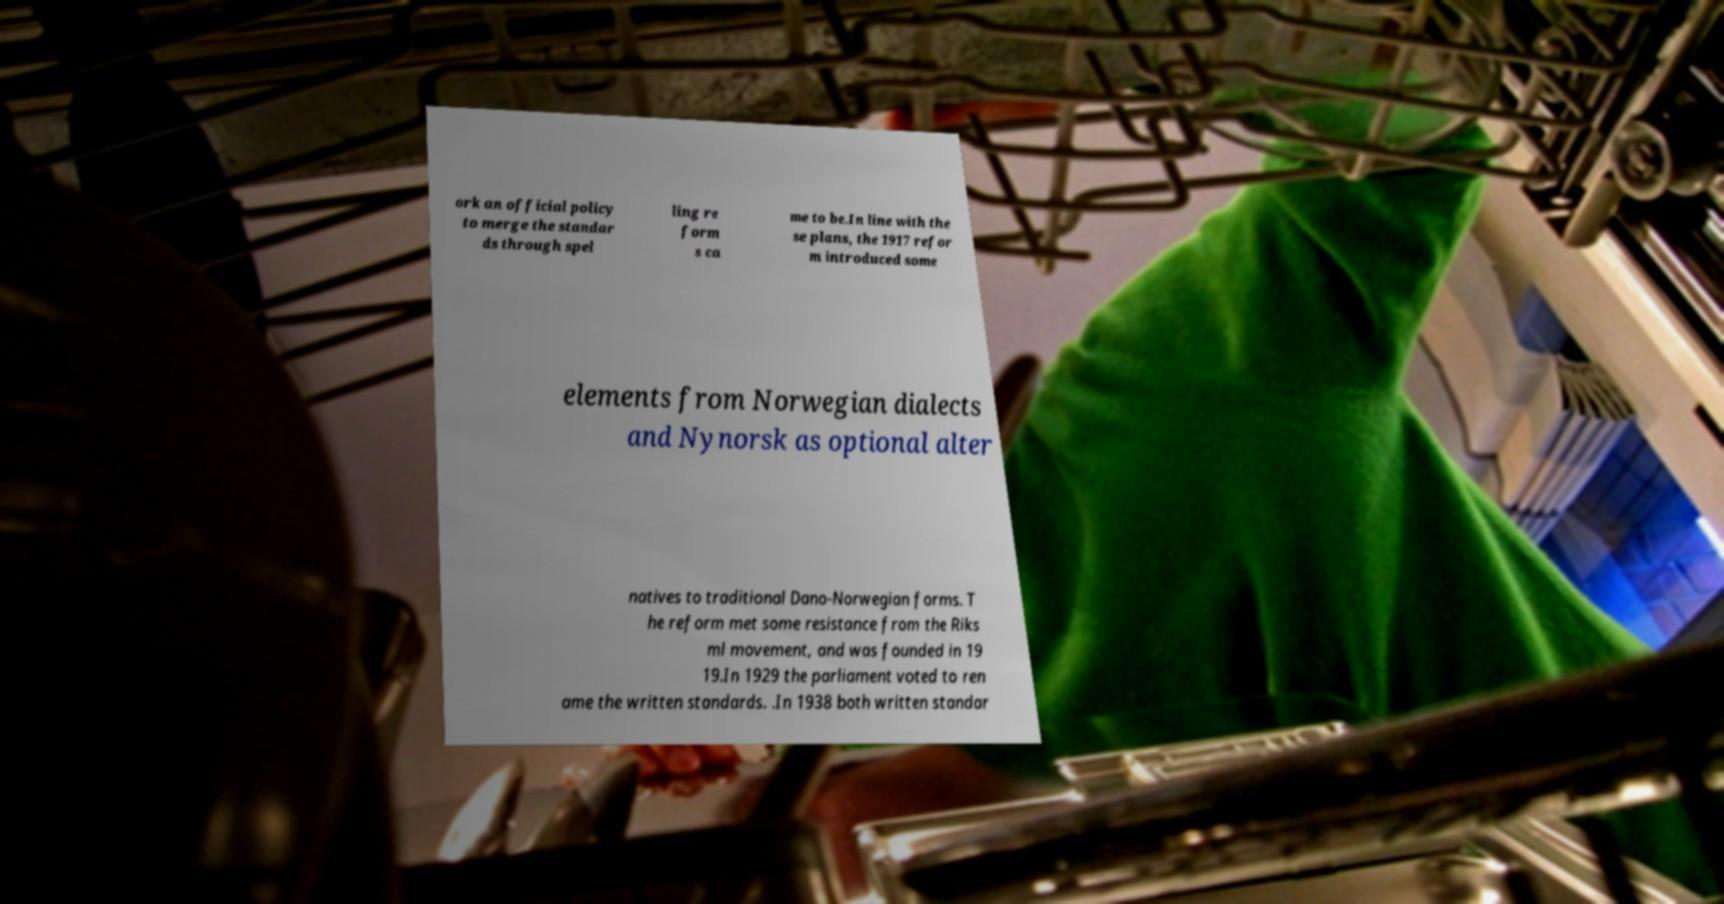Could you extract and type out the text from this image? ork an official policy to merge the standar ds through spel ling re form s ca me to be.In line with the se plans, the 1917 refor m introduced some elements from Norwegian dialects and Nynorsk as optional alter natives to traditional Dano-Norwegian forms. T he reform met some resistance from the Riks ml movement, and was founded in 19 19.In 1929 the parliament voted to ren ame the written standards. .In 1938 both written standar 